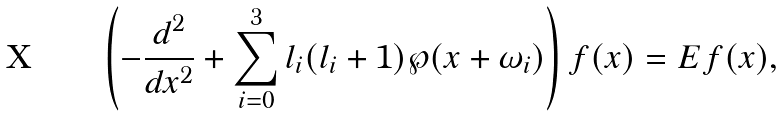<formula> <loc_0><loc_0><loc_500><loc_500>\left ( - \frac { d ^ { 2 } } { d x ^ { 2 } } + \sum _ { i = 0 } ^ { 3 } l _ { i } ( l _ { i } + 1 ) \wp ( x + \omega _ { i } ) \right ) f ( x ) = E f ( x ) ,</formula> 